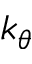Convert formula to latex. <formula><loc_0><loc_0><loc_500><loc_500>k _ { \theta }</formula> 